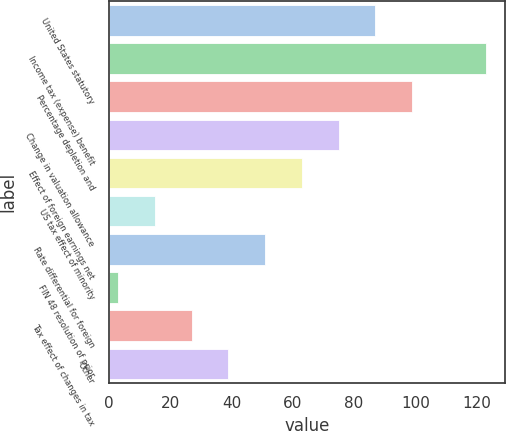Convert chart to OTSL. <chart><loc_0><loc_0><loc_500><loc_500><bar_chart><fcel>United States statutory<fcel>Income tax (expense) benefit<fcel>Percentage depletion and<fcel>Change in valuation allowance<fcel>Effect of foreign earnings net<fcel>US tax effect of minority<fcel>Rate differential for foreign<fcel>FIN 48 resolution of prior<fcel>Tax effect of changes in tax<fcel>Other<nl><fcel>87<fcel>123<fcel>99<fcel>75<fcel>63<fcel>15<fcel>51<fcel>3<fcel>27<fcel>39<nl></chart> 